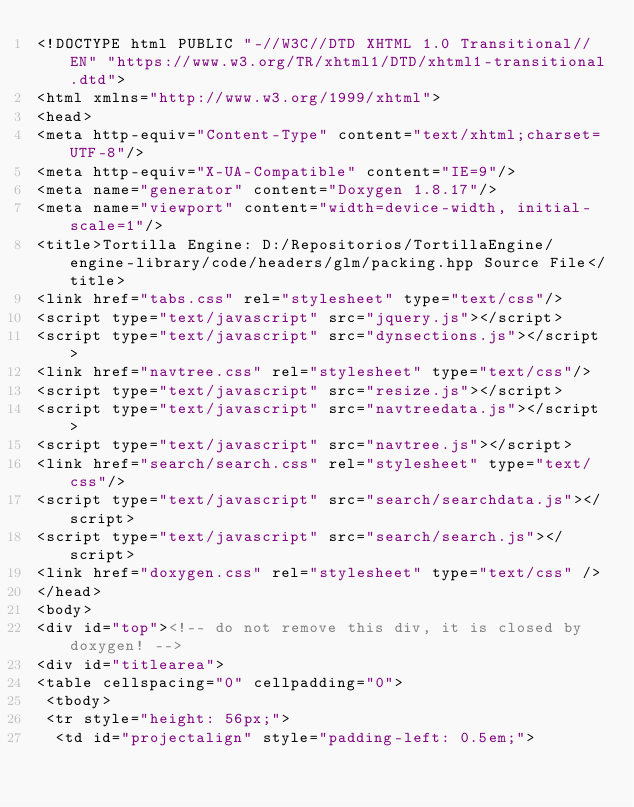Convert code to text. <code><loc_0><loc_0><loc_500><loc_500><_HTML_><!DOCTYPE html PUBLIC "-//W3C//DTD XHTML 1.0 Transitional//EN" "https://www.w3.org/TR/xhtml1/DTD/xhtml1-transitional.dtd">
<html xmlns="http://www.w3.org/1999/xhtml">
<head>
<meta http-equiv="Content-Type" content="text/xhtml;charset=UTF-8"/>
<meta http-equiv="X-UA-Compatible" content="IE=9"/>
<meta name="generator" content="Doxygen 1.8.17"/>
<meta name="viewport" content="width=device-width, initial-scale=1"/>
<title>Tortilla Engine: D:/Repositorios/TortillaEngine/engine-library/code/headers/glm/packing.hpp Source File</title>
<link href="tabs.css" rel="stylesheet" type="text/css"/>
<script type="text/javascript" src="jquery.js"></script>
<script type="text/javascript" src="dynsections.js"></script>
<link href="navtree.css" rel="stylesheet" type="text/css"/>
<script type="text/javascript" src="resize.js"></script>
<script type="text/javascript" src="navtreedata.js"></script>
<script type="text/javascript" src="navtree.js"></script>
<link href="search/search.css" rel="stylesheet" type="text/css"/>
<script type="text/javascript" src="search/searchdata.js"></script>
<script type="text/javascript" src="search/search.js"></script>
<link href="doxygen.css" rel="stylesheet" type="text/css" />
</head>
<body>
<div id="top"><!-- do not remove this div, it is closed by doxygen! -->
<div id="titlearea">
<table cellspacing="0" cellpadding="0">
 <tbody>
 <tr style="height: 56px;">
  <td id="projectalign" style="padding-left: 0.5em;"></code> 